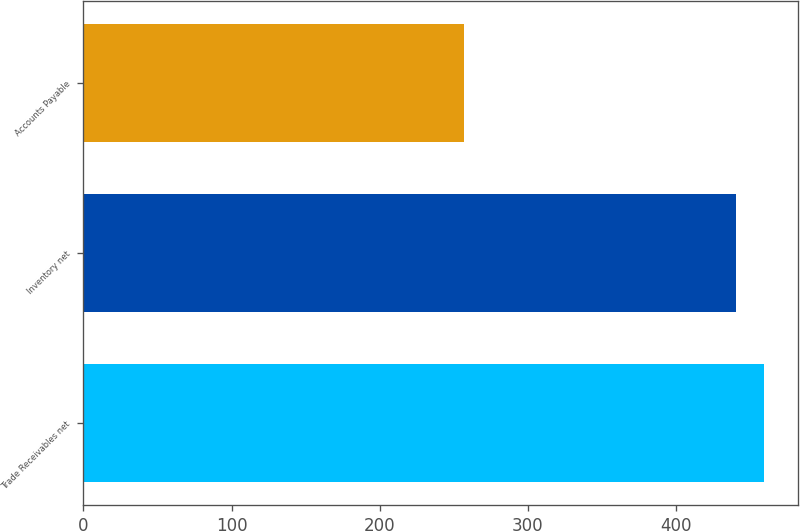Convert chart to OTSL. <chart><loc_0><loc_0><loc_500><loc_500><bar_chart><fcel>Trade Receivables net<fcel>Inventory net<fcel>Accounts Payable<nl><fcel>459.5<fcel>441<fcel>257<nl></chart> 